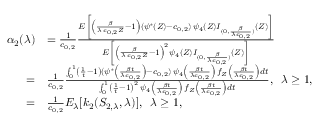<formula> <loc_0><loc_0><loc_500><loc_500>\begin{array} { r l } { \alpha _ { 2 } ( \lambda ) } & { = \frac { 1 } { c _ { 0 , 2 } } \frac { E \left [ \left ( \frac { \beta } { \lambda \, c _ { 0 , 2 } Z } - 1 \right ) ( \psi ^ { * } ( Z ) - c _ { 0 , 2 } ) \, \psi _ { 4 } ( Z ) I _ { ( 0 , \frac { \beta } { \lambda c _ { 0 , 2 } } ) } ( Z ) \right ] } { E \left [ \left ( \frac { \beta } { \lambda \, c _ { 0 , 2 } Z } - 1 \right ) ^ { 2 } \psi _ { 4 } ( Z ) I _ { ( 0 , \frac { \beta } { \lambda c _ { 0 , 2 } } ) } ( Z ) \right ] } } \\ { = } & { \frac { 1 } { c _ { 0 , 2 } } \frac { \int _ { 0 } ^ { 1 } \left ( \frac { 1 } { t } - 1 \right ) ( \psi ^ { * } \left ( \frac { \beta t } { \lambda c _ { 0 , 2 } } \right ) - c _ { 0 , 2 } ) \, \psi _ { 4 } \left ( \frac { \beta t } { \lambda c _ { 0 , 2 } } \right ) \, f _ { Z } \left ( \frac { \beta t } { \lambda c _ { 0 , 2 } } \right ) d t } { \int _ { 0 } ^ { 1 } \left ( \frac { 1 } { t } - 1 \right ) ^ { 2 } \, \psi _ { 4 } \left ( \frac { \beta t } { \lambda c _ { 0 , 2 } } \right ) \, f _ { Z } \left ( \frac { \beta t } { \lambda c _ { 0 , 2 } } \right ) d t } , \, \lambda \geq 1 , } \\ { = } & { \frac { 1 } { c _ { 0 , 2 } } E _ { \lambda } [ k _ { 2 } ( S _ { 2 , \lambda } , \lambda ) ] , \, \lambda \geq 1 , } \end{array}</formula> 